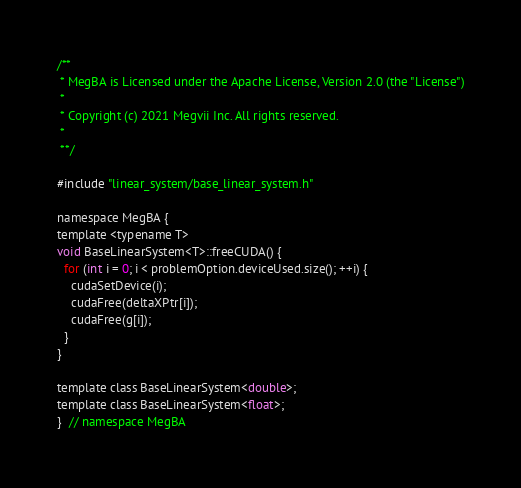<code> <loc_0><loc_0><loc_500><loc_500><_Cuda_>/**
 * MegBA is Licensed under the Apache License, Version 2.0 (the "License")
 *
 * Copyright (c) 2021 Megvii Inc. All rights reserved.
 *
 **/

#include "linear_system/base_linear_system.h"

namespace MegBA {
template <typename T>
void BaseLinearSystem<T>::freeCUDA() {
  for (int i = 0; i < problemOption.deviceUsed.size(); ++i) {
    cudaSetDevice(i);
    cudaFree(deltaXPtr[i]);
    cudaFree(g[i]);
  }
}

template class BaseLinearSystem<double>;
template class BaseLinearSystem<float>;
}  // namespace MegBA
</code> 